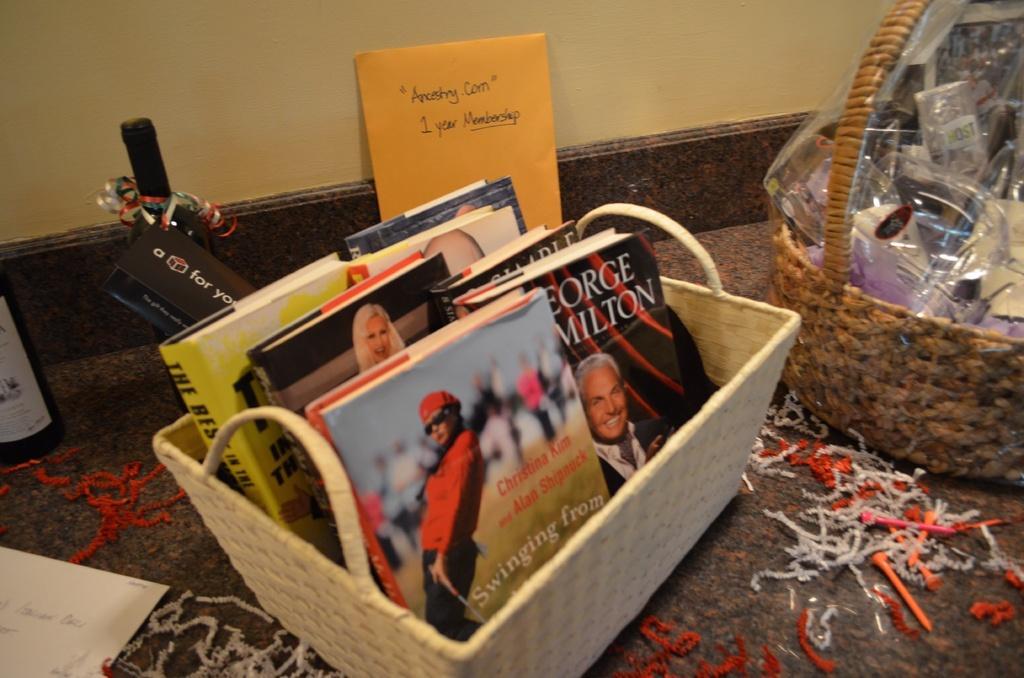Describe this image in one or two sentences. In this image there are baskets and we can see books and some things placed in the baskets. At the bottom there is a floor and we can see cards and bottles placed on the floor. In the background there is a wall. 